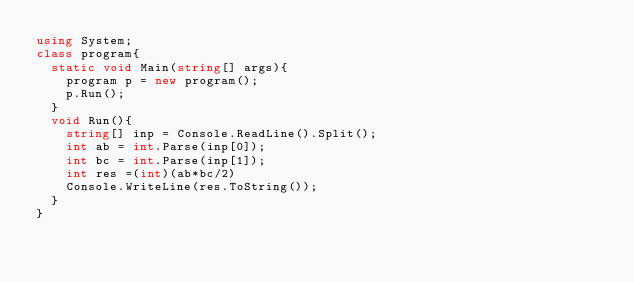<code> <loc_0><loc_0><loc_500><loc_500><_C#_>using System;
class program{
  static void Main(string[] args){
    program p = new program();
    p.Run();
  }
  void Run(){
	string[] inp = Console.ReadLine().Split();
   	int ab = int.Parse(inp[0]);
   	int bc = int.Parse(inp[1]);
    int res =(int)(ab*bc/2)
   	Console.WriteLine(res.ToString());
  }
}
</code> 